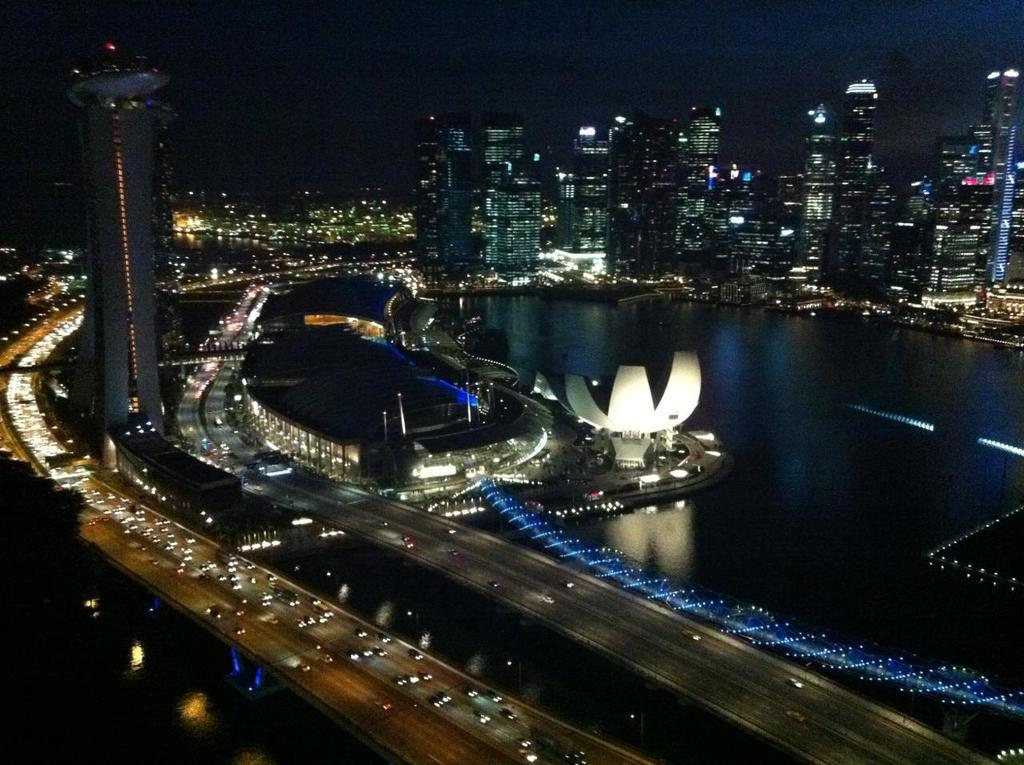What can be seen moving on the roads in the image? There are vehicles on the roads in the image. What type of natural or man-made feature is visible in the image? There is a water surface visible in the image. What type of structures can be seen in the image? There are architectures present in the image. How many buildings can be seen in the image? There are many buildings in the image. Can you tell me where the hen is located in the image? There is no hen present in the image. What type of sister can be seen interacting with the buildings in the image? There is no sister present in the image, and the buildings are not interacting with any individuals. 